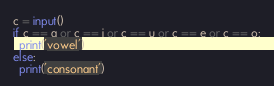Convert code to text. <code><loc_0><loc_0><loc_500><loc_500><_Python_>c = input()
if c == a or c == i or c == u or c == e or c == o:
  print('vowel')
else:
  print('consonant')</code> 